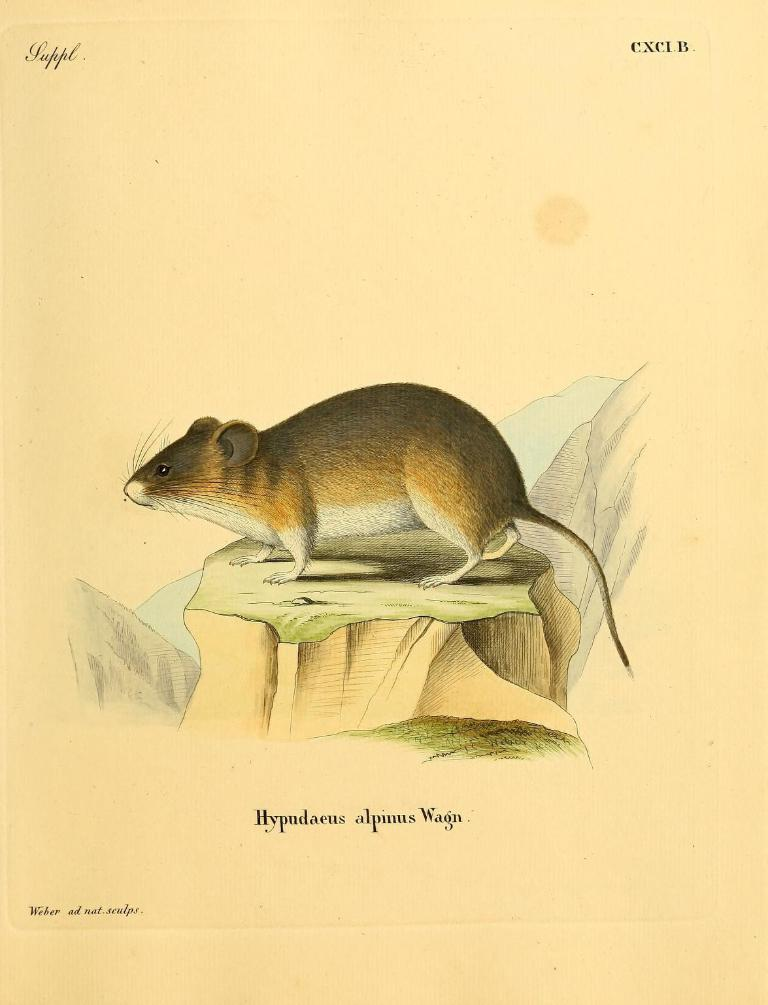What is the main subject of the image? The main subject of the image is a drawing of a rat. Can you describe the colors of the rat? The rat is brown, black, and cream in color. What is the rat sitting on in the image? The rat is on a green and brown colored object. What color is the background of the image? The background of the image is cream colored. What type of suit is the rat wearing in the image? There is no suit present in the image; the rat is a drawing and does not wear clothing. 